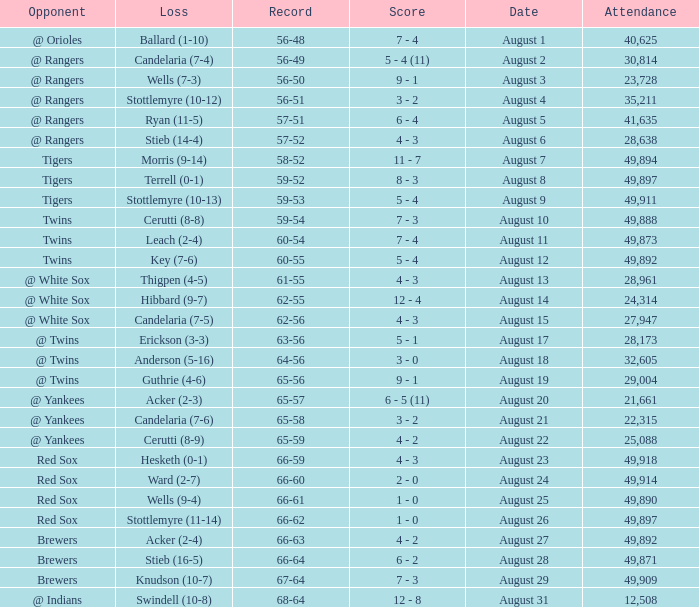What was the record of the game that had a loss of Stottlemyre (10-12)? 56-51. 